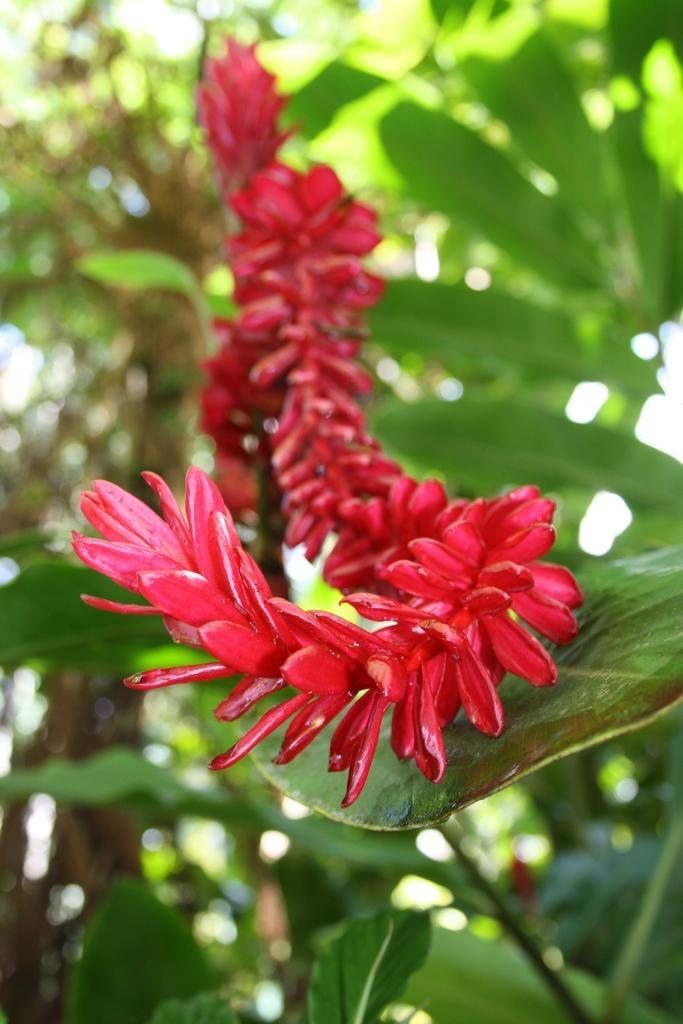Can you describe this image briefly? In this image I can see the flowers to the plants. I can see these flowers are in red color. And there is a blurred background. 